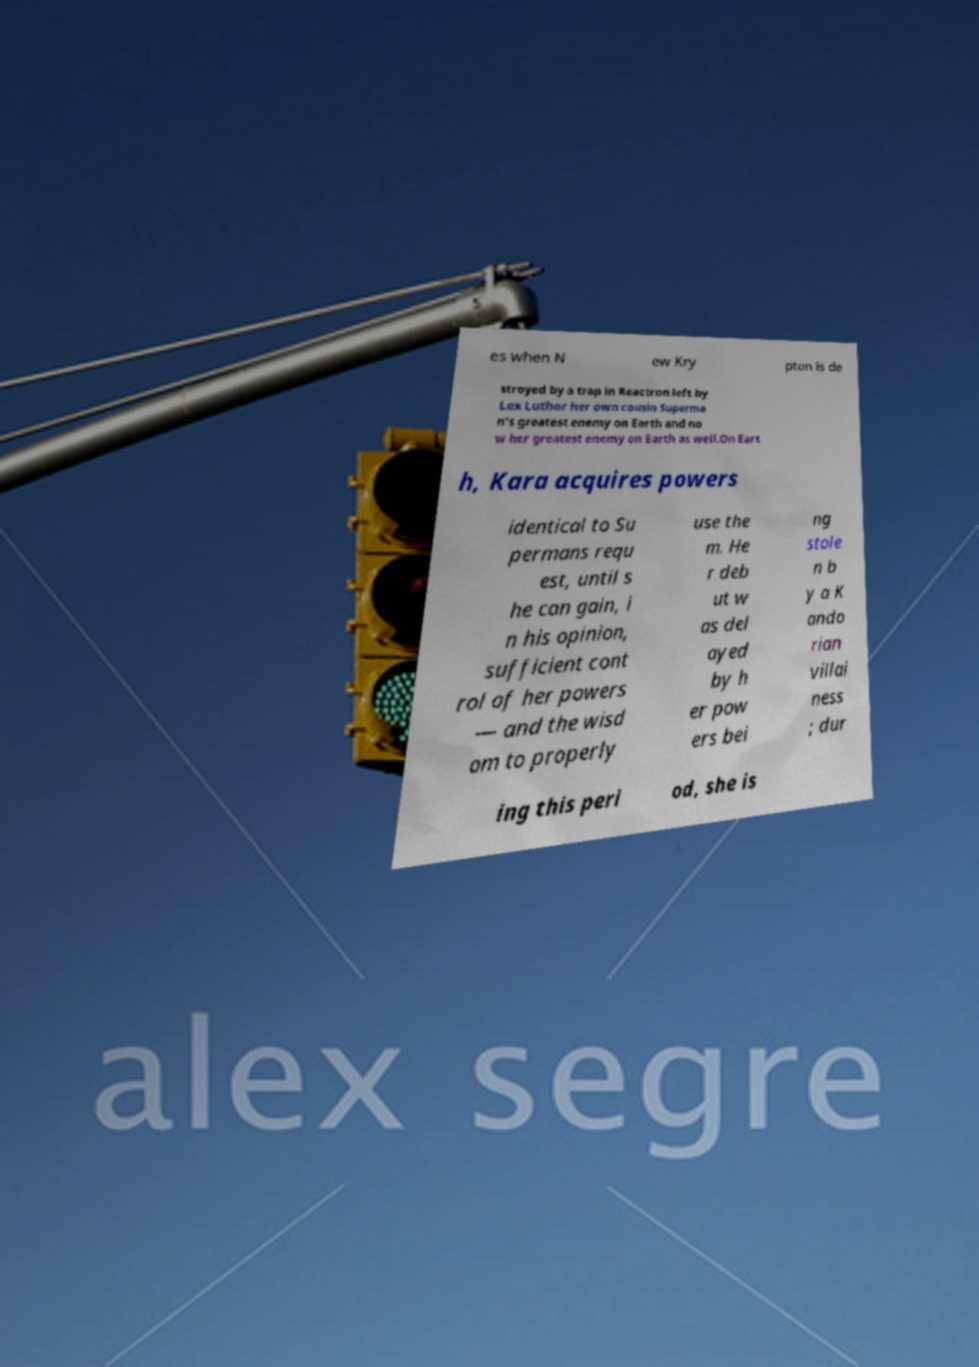For documentation purposes, I need the text within this image transcribed. Could you provide that? es when N ew Kry pton is de stroyed by a trap in Reactron left by Lex Luthor her own cousin Superma n's greatest enemy on Earth and no w her greatest enemy on Earth as well.On Eart h, Kara acquires powers identical to Su permans requ est, until s he can gain, i n his opinion, sufficient cont rol of her powers — and the wisd om to properly use the m. He r deb ut w as del ayed by h er pow ers bei ng stole n b y a K ando rian villai ness ; dur ing this peri od, she is 